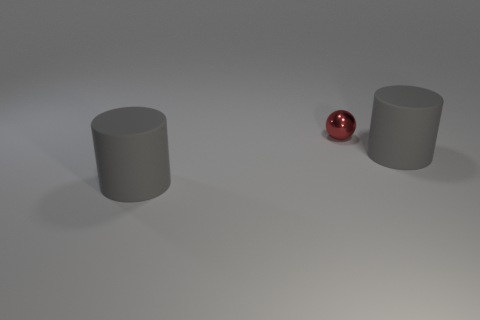What is the color of the tiny shiny ball? The tiny ball in the image has a glossy finish with a rich red hue that reflects the surrounding light, giving it a vibrant and eye-catching appearance. 